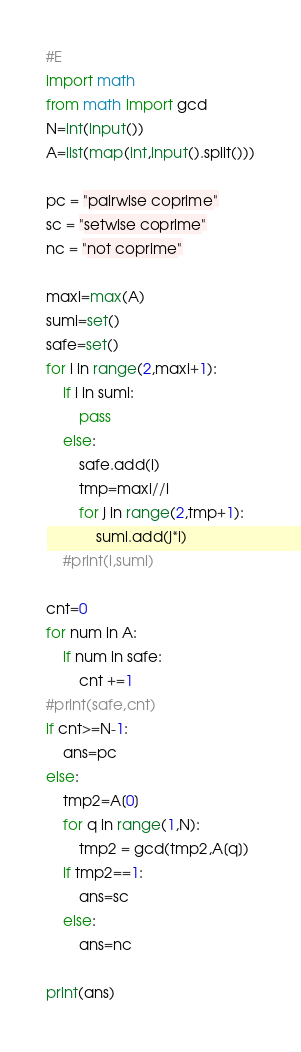<code> <loc_0><loc_0><loc_500><loc_500><_Python_>#E
import math
from math import gcd
N=int(input())
A=list(map(int,input().split()))

pc = "pairwise coprime"
sc = "setwise coprime"
nc = "not coprime"

maxi=max(A)
sumi=set()
safe=set()
for i in range(2,maxi+1):
    if i in sumi:
        pass
    else:
        safe.add(i)
        tmp=maxi//i
        for j in range(2,tmp+1):
            sumi.add(j*i)
    #print(i,sumi)

cnt=0
for num in A:
    if num in safe:
        cnt +=1
#print(safe,cnt)
if cnt>=N-1:
    ans=pc
else:
    tmp2=A[0]
    for q in range(1,N):
        tmp2 = gcd(tmp2,A[q])
    if tmp2==1:
        ans=sc
    else:
        ans=nc

print(ans)</code> 